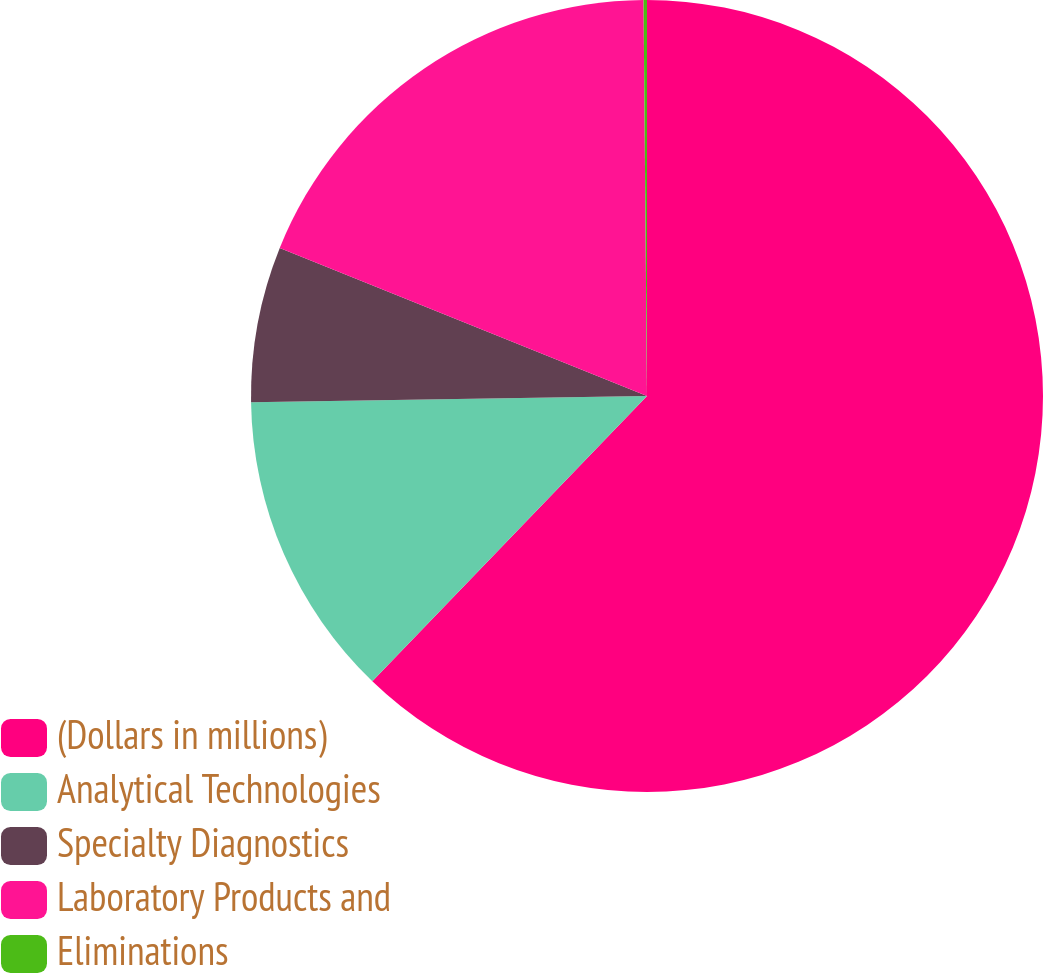Convert chart to OTSL. <chart><loc_0><loc_0><loc_500><loc_500><pie_chart><fcel>(Dollars in millions)<fcel>Analytical Technologies<fcel>Specialty Diagnostics<fcel>Laboratory Products and<fcel>Eliminations<nl><fcel>62.2%<fcel>12.55%<fcel>6.35%<fcel>18.76%<fcel>0.14%<nl></chart> 